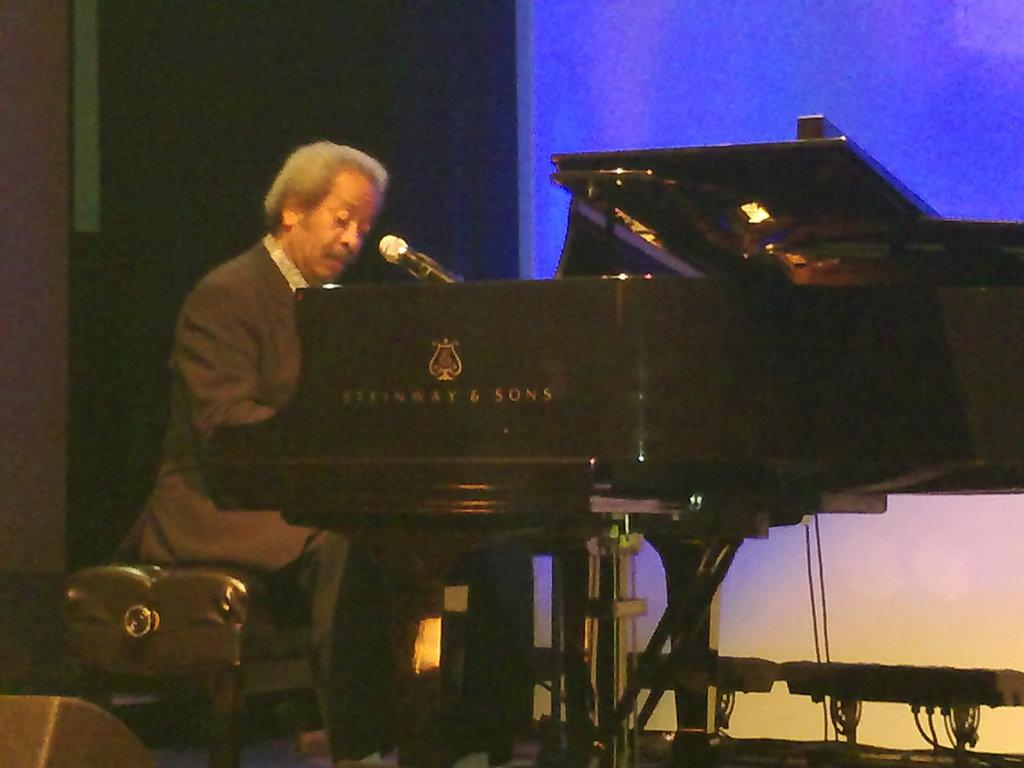Who is the main subject in the image? There is a man in the image. What is the man doing in the image? The man is playing a musical instrument. What is the man's position in the image? The man is sitting on a chair. What type of camp can be seen in the background of the image? There is no camp visible in the image; it only features a man sitting on a chair and playing a musical instrument. 